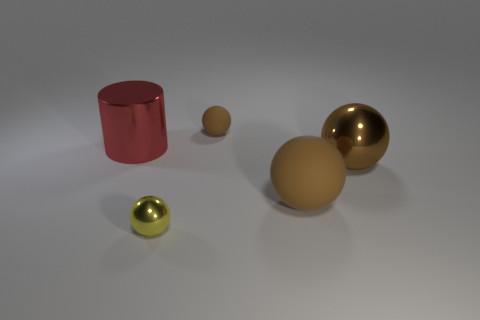What size is the metal sphere that is the same color as the large rubber ball?
Offer a very short reply. Large. What number of other spheres have the same color as the small metallic sphere?
Provide a succinct answer. 0. Is the color of the tiny shiny sphere the same as the cylinder?
Offer a very short reply. No. What color is the big cylinder?
Your answer should be compact. Red. Is there any other thing that has the same material as the big cylinder?
Your answer should be compact. Yes. What number of objects are large shiny objects on the right side of the red metal cylinder or big brown shiny objects that are on the right side of the tiny brown ball?
Give a very brief answer. 1. Do the red cylinder and the tiny ball in front of the small brown thing have the same material?
Make the answer very short. Yes. What is the shape of the thing that is right of the red shiny cylinder and behind the big metallic sphere?
Your response must be concise. Sphere. How many other things are there of the same color as the big metal ball?
Offer a terse response. 2. The brown metallic thing is what shape?
Provide a succinct answer. Sphere. 